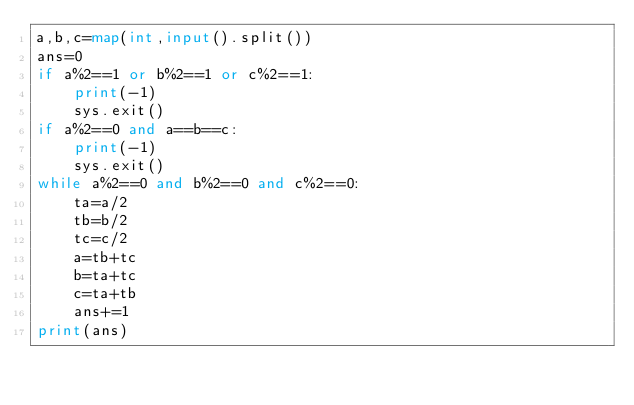<code> <loc_0><loc_0><loc_500><loc_500><_Python_>a,b,c=map(int,input().split())
ans=0
if a%2==1 or b%2==1 or c%2==1:
    print(-1)
    sys.exit()
if a%2==0 and a==b==c:
    print(-1)
    sys.exit()
while a%2==0 and b%2==0 and c%2==0:
    ta=a/2
    tb=b/2
    tc=c/2
    a=tb+tc
    b=ta+tc
    c=ta+tb
    ans+=1
print(ans)</code> 